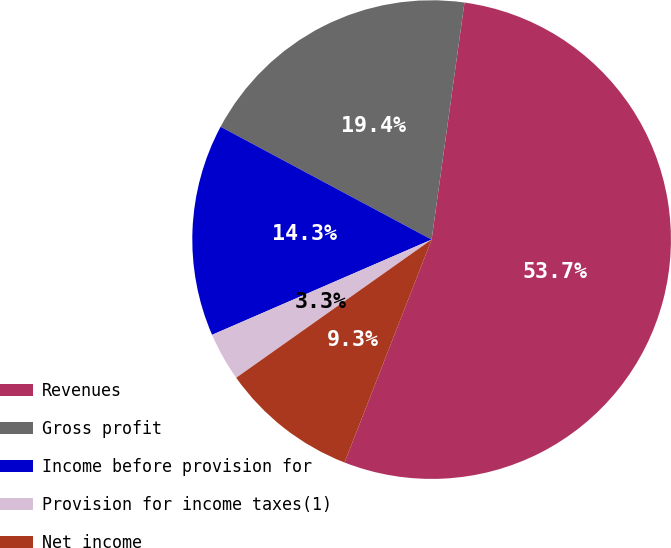Convert chart to OTSL. <chart><loc_0><loc_0><loc_500><loc_500><pie_chart><fcel>Revenues<fcel>Gross profit<fcel>Income before provision for<fcel>Provision for income taxes(1)<fcel>Net income<nl><fcel>53.74%<fcel>19.38%<fcel>14.33%<fcel>3.28%<fcel>9.28%<nl></chart> 